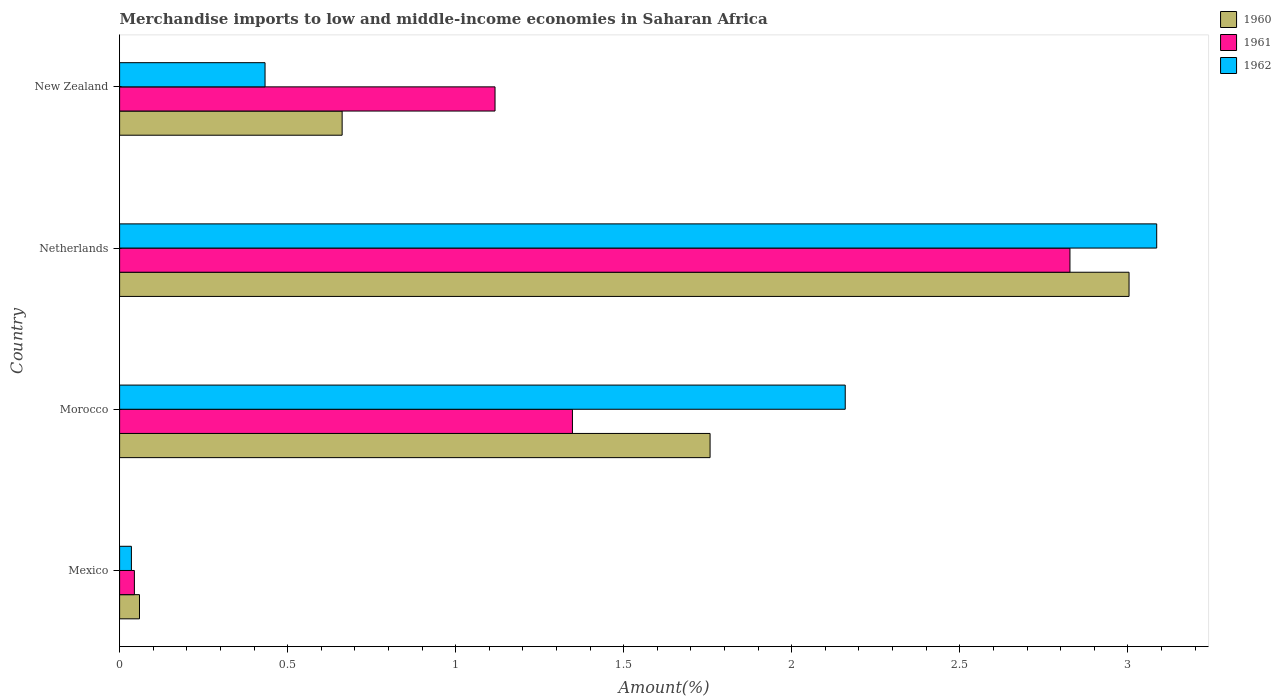How many different coloured bars are there?
Provide a succinct answer. 3. Are the number of bars per tick equal to the number of legend labels?
Provide a short and direct response. Yes. How many bars are there on the 3rd tick from the top?
Make the answer very short. 3. How many bars are there on the 1st tick from the bottom?
Your response must be concise. 3. What is the label of the 3rd group of bars from the top?
Offer a terse response. Morocco. In how many cases, is the number of bars for a given country not equal to the number of legend labels?
Make the answer very short. 0. What is the percentage of amount earned from merchandise imports in 1960 in New Zealand?
Your answer should be compact. 0.66. Across all countries, what is the maximum percentage of amount earned from merchandise imports in 1960?
Offer a very short reply. 3. Across all countries, what is the minimum percentage of amount earned from merchandise imports in 1961?
Your response must be concise. 0.04. In which country was the percentage of amount earned from merchandise imports in 1961 maximum?
Your answer should be compact. Netherlands. What is the total percentage of amount earned from merchandise imports in 1961 in the graph?
Your response must be concise. 5.34. What is the difference between the percentage of amount earned from merchandise imports in 1961 in Mexico and that in Netherlands?
Keep it short and to the point. -2.78. What is the difference between the percentage of amount earned from merchandise imports in 1961 in New Zealand and the percentage of amount earned from merchandise imports in 1962 in Netherlands?
Keep it short and to the point. -1.97. What is the average percentage of amount earned from merchandise imports in 1962 per country?
Provide a succinct answer. 1.43. What is the difference between the percentage of amount earned from merchandise imports in 1960 and percentage of amount earned from merchandise imports in 1961 in Morocco?
Offer a very short reply. 0.41. What is the ratio of the percentage of amount earned from merchandise imports in 1960 in Mexico to that in Morocco?
Give a very brief answer. 0.03. Is the percentage of amount earned from merchandise imports in 1962 in Mexico less than that in Netherlands?
Your answer should be compact. Yes. What is the difference between the highest and the second highest percentage of amount earned from merchandise imports in 1961?
Keep it short and to the point. 1.48. What is the difference between the highest and the lowest percentage of amount earned from merchandise imports in 1961?
Offer a very short reply. 2.78. What does the 3rd bar from the top in New Zealand represents?
Make the answer very short. 1960. How many bars are there?
Give a very brief answer. 12. Are all the bars in the graph horizontal?
Provide a succinct answer. Yes. What is the difference between two consecutive major ticks on the X-axis?
Provide a short and direct response. 0.5. Does the graph contain grids?
Your answer should be very brief. No. How many legend labels are there?
Your response must be concise. 3. How are the legend labels stacked?
Your answer should be compact. Vertical. What is the title of the graph?
Keep it short and to the point. Merchandise imports to low and middle-income economies in Saharan Africa. What is the label or title of the X-axis?
Keep it short and to the point. Amount(%). What is the Amount(%) in 1960 in Mexico?
Provide a succinct answer. 0.06. What is the Amount(%) in 1961 in Mexico?
Your response must be concise. 0.04. What is the Amount(%) in 1962 in Mexico?
Ensure brevity in your answer.  0.04. What is the Amount(%) of 1960 in Morocco?
Your response must be concise. 1.76. What is the Amount(%) of 1961 in Morocco?
Ensure brevity in your answer.  1.35. What is the Amount(%) in 1962 in Morocco?
Keep it short and to the point. 2.16. What is the Amount(%) in 1960 in Netherlands?
Ensure brevity in your answer.  3. What is the Amount(%) of 1961 in Netherlands?
Offer a very short reply. 2.83. What is the Amount(%) in 1962 in Netherlands?
Offer a very short reply. 3.09. What is the Amount(%) in 1960 in New Zealand?
Offer a very short reply. 0.66. What is the Amount(%) in 1961 in New Zealand?
Make the answer very short. 1.12. What is the Amount(%) of 1962 in New Zealand?
Provide a succinct answer. 0.43. Across all countries, what is the maximum Amount(%) in 1960?
Your response must be concise. 3. Across all countries, what is the maximum Amount(%) of 1961?
Make the answer very short. 2.83. Across all countries, what is the maximum Amount(%) of 1962?
Give a very brief answer. 3.09. Across all countries, what is the minimum Amount(%) of 1960?
Your response must be concise. 0.06. Across all countries, what is the minimum Amount(%) of 1961?
Give a very brief answer. 0.04. Across all countries, what is the minimum Amount(%) of 1962?
Ensure brevity in your answer.  0.04. What is the total Amount(%) of 1960 in the graph?
Ensure brevity in your answer.  5.48. What is the total Amount(%) in 1961 in the graph?
Offer a terse response. 5.34. What is the total Amount(%) in 1962 in the graph?
Your response must be concise. 5.71. What is the difference between the Amount(%) of 1960 in Mexico and that in Morocco?
Keep it short and to the point. -1.7. What is the difference between the Amount(%) in 1961 in Mexico and that in Morocco?
Give a very brief answer. -1.3. What is the difference between the Amount(%) in 1962 in Mexico and that in Morocco?
Ensure brevity in your answer.  -2.12. What is the difference between the Amount(%) of 1960 in Mexico and that in Netherlands?
Your response must be concise. -2.94. What is the difference between the Amount(%) in 1961 in Mexico and that in Netherlands?
Offer a terse response. -2.78. What is the difference between the Amount(%) of 1962 in Mexico and that in Netherlands?
Provide a short and direct response. -3.05. What is the difference between the Amount(%) of 1960 in Mexico and that in New Zealand?
Provide a short and direct response. -0.6. What is the difference between the Amount(%) in 1961 in Mexico and that in New Zealand?
Provide a succinct answer. -1.07. What is the difference between the Amount(%) of 1962 in Mexico and that in New Zealand?
Provide a succinct answer. -0.4. What is the difference between the Amount(%) of 1960 in Morocco and that in Netherlands?
Your answer should be very brief. -1.25. What is the difference between the Amount(%) in 1961 in Morocco and that in Netherlands?
Offer a very short reply. -1.48. What is the difference between the Amount(%) of 1962 in Morocco and that in Netherlands?
Make the answer very short. -0.93. What is the difference between the Amount(%) in 1960 in Morocco and that in New Zealand?
Provide a short and direct response. 1.09. What is the difference between the Amount(%) in 1961 in Morocco and that in New Zealand?
Give a very brief answer. 0.23. What is the difference between the Amount(%) of 1962 in Morocco and that in New Zealand?
Offer a very short reply. 1.73. What is the difference between the Amount(%) of 1960 in Netherlands and that in New Zealand?
Offer a terse response. 2.34. What is the difference between the Amount(%) in 1961 in Netherlands and that in New Zealand?
Ensure brevity in your answer.  1.71. What is the difference between the Amount(%) in 1962 in Netherlands and that in New Zealand?
Provide a succinct answer. 2.65. What is the difference between the Amount(%) of 1960 in Mexico and the Amount(%) of 1961 in Morocco?
Keep it short and to the point. -1.29. What is the difference between the Amount(%) in 1960 in Mexico and the Amount(%) in 1962 in Morocco?
Provide a succinct answer. -2.1. What is the difference between the Amount(%) of 1961 in Mexico and the Amount(%) of 1962 in Morocco?
Keep it short and to the point. -2.12. What is the difference between the Amount(%) of 1960 in Mexico and the Amount(%) of 1961 in Netherlands?
Provide a short and direct response. -2.77. What is the difference between the Amount(%) of 1960 in Mexico and the Amount(%) of 1962 in Netherlands?
Provide a short and direct response. -3.03. What is the difference between the Amount(%) of 1961 in Mexico and the Amount(%) of 1962 in Netherlands?
Offer a very short reply. -3.04. What is the difference between the Amount(%) in 1960 in Mexico and the Amount(%) in 1961 in New Zealand?
Make the answer very short. -1.06. What is the difference between the Amount(%) in 1960 in Mexico and the Amount(%) in 1962 in New Zealand?
Give a very brief answer. -0.37. What is the difference between the Amount(%) of 1961 in Mexico and the Amount(%) of 1962 in New Zealand?
Offer a very short reply. -0.39. What is the difference between the Amount(%) in 1960 in Morocco and the Amount(%) in 1961 in Netherlands?
Offer a very short reply. -1.07. What is the difference between the Amount(%) of 1960 in Morocco and the Amount(%) of 1962 in Netherlands?
Your response must be concise. -1.33. What is the difference between the Amount(%) of 1961 in Morocco and the Amount(%) of 1962 in Netherlands?
Offer a terse response. -1.74. What is the difference between the Amount(%) of 1960 in Morocco and the Amount(%) of 1961 in New Zealand?
Your answer should be compact. 0.64. What is the difference between the Amount(%) in 1960 in Morocco and the Amount(%) in 1962 in New Zealand?
Provide a succinct answer. 1.32. What is the difference between the Amount(%) of 1961 in Morocco and the Amount(%) of 1962 in New Zealand?
Your response must be concise. 0.91. What is the difference between the Amount(%) of 1960 in Netherlands and the Amount(%) of 1961 in New Zealand?
Keep it short and to the point. 1.89. What is the difference between the Amount(%) in 1960 in Netherlands and the Amount(%) in 1962 in New Zealand?
Provide a short and direct response. 2.57. What is the difference between the Amount(%) of 1961 in Netherlands and the Amount(%) of 1962 in New Zealand?
Your answer should be very brief. 2.4. What is the average Amount(%) of 1960 per country?
Make the answer very short. 1.37. What is the average Amount(%) of 1961 per country?
Your answer should be compact. 1.33. What is the average Amount(%) in 1962 per country?
Offer a very short reply. 1.43. What is the difference between the Amount(%) in 1960 and Amount(%) in 1961 in Mexico?
Provide a succinct answer. 0.02. What is the difference between the Amount(%) in 1960 and Amount(%) in 1962 in Mexico?
Give a very brief answer. 0.02. What is the difference between the Amount(%) in 1961 and Amount(%) in 1962 in Mexico?
Ensure brevity in your answer.  0.01. What is the difference between the Amount(%) in 1960 and Amount(%) in 1961 in Morocco?
Your answer should be compact. 0.41. What is the difference between the Amount(%) in 1960 and Amount(%) in 1962 in Morocco?
Your answer should be very brief. -0.4. What is the difference between the Amount(%) in 1961 and Amount(%) in 1962 in Morocco?
Keep it short and to the point. -0.81. What is the difference between the Amount(%) of 1960 and Amount(%) of 1961 in Netherlands?
Give a very brief answer. 0.18. What is the difference between the Amount(%) in 1960 and Amount(%) in 1962 in Netherlands?
Keep it short and to the point. -0.08. What is the difference between the Amount(%) of 1961 and Amount(%) of 1962 in Netherlands?
Give a very brief answer. -0.26. What is the difference between the Amount(%) of 1960 and Amount(%) of 1961 in New Zealand?
Provide a succinct answer. -0.46. What is the difference between the Amount(%) of 1960 and Amount(%) of 1962 in New Zealand?
Your answer should be compact. 0.23. What is the difference between the Amount(%) in 1961 and Amount(%) in 1962 in New Zealand?
Keep it short and to the point. 0.68. What is the ratio of the Amount(%) of 1960 in Mexico to that in Morocco?
Keep it short and to the point. 0.03. What is the ratio of the Amount(%) of 1961 in Mexico to that in Morocco?
Make the answer very short. 0.03. What is the ratio of the Amount(%) in 1962 in Mexico to that in Morocco?
Ensure brevity in your answer.  0.02. What is the ratio of the Amount(%) in 1960 in Mexico to that in Netherlands?
Your answer should be compact. 0.02. What is the ratio of the Amount(%) of 1961 in Mexico to that in Netherlands?
Offer a terse response. 0.02. What is the ratio of the Amount(%) of 1962 in Mexico to that in Netherlands?
Your answer should be very brief. 0.01. What is the ratio of the Amount(%) of 1960 in Mexico to that in New Zealand?
Your answer should be very brief. 0.09. What is the ratio of the Amount(%) in 1961 in Mexico to that in New Zealand?
Keep it short and to the point. 0.04. What is the ratio of the Amount(%) in 1962 in Mexico to that in New Zealand?
Offer a terse response. 0.08. What is the ratio of the Amount(%) in 1960 in Morocco to that in Netherlands?
Ensure brevity in your answer.  0.58. What is the ratio of the Amount(%) of 1961 in Morocco to that in Netherlands?
Keep it short and to the point. 0.48. What is the ratio of the Amount(%) in 1962 in Morocco to that in Netherlands?
Offer a terse response. 0.7. What is the ratio of the Amount(%) in 1960 in Morocco to that in New Zealand?
Keep it short and to the point. 2.65. What is the ratio of the Amount(%) in 1961 in Morocco to that in New Zealand?
Your response must be concise. 1.21. What is the ratio of the Amount(%) of 1962 in Morocco to that in New Zealand?
Your answer should be compact. 4.99. What is the ratio of the Amount(%) of 1960 in Netherlands to that in New Zealand?
Ensure brevity in your answer.  4.54. What is the ratio of the Amount(%) in 1961 in Netherlands to that in New Zealand?
Your response must be concise. 2.53. What is the ratio of the Amount(%) of 1962 in Netherlands to that in New Zealand?
Give a very brief answer. 7.13. What is the difference between the highest and the second highest Amount(%) of 1960?
Your response must be concise. 1.25. What is the difference between the highest and the second highest Amount(%) of 1961?
Provide a short and direct response. 1.48. What is the difference between the highest and the second highest Amount(%) of 1962?
Provide a short and direct response. 0.93. What is the difference between the highest and the lowest Amount(%) in 1960?
Offer a terse response. 2.94. What is the difference between the highest and the lowest Amount(%) of 1961?
Provide a short and direct response. 2.78. What is the difference between the highest and the lowest Amount(%) of 1962?
Your answer should be very brief. 3.05. 